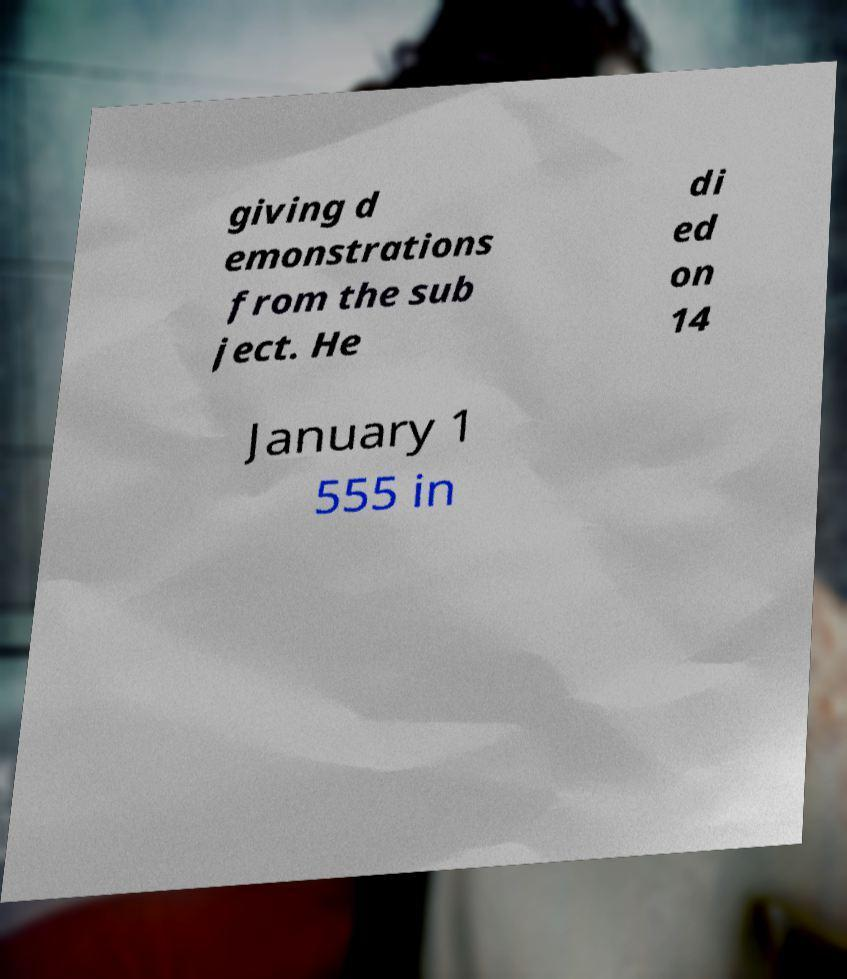Please identify and transcribe the text found in this image. giving d emonstrations from the sub ject. He di ed on 14 January 1 555 in 